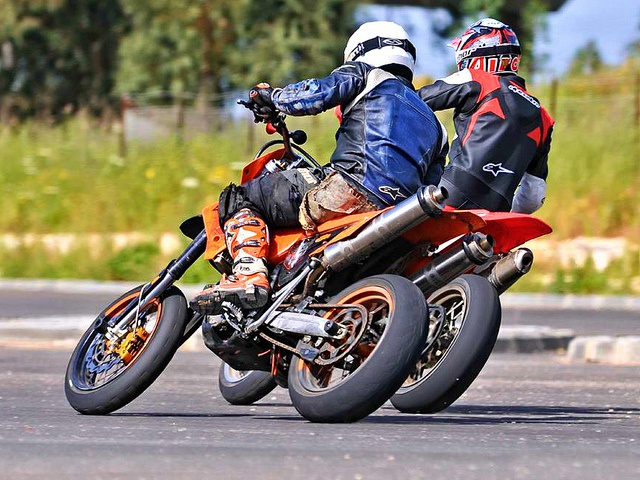Describe the objects in this image and their specific colors. I can see motorcycle in tan, black, gray, darkgray, and lightgray tones, people in tan, black, white, gray, and blue tones, people in tan, black, gray, navy, and lavender tones, and motorcycle in tan, black, gray, brown, and maroon tones in this image. 